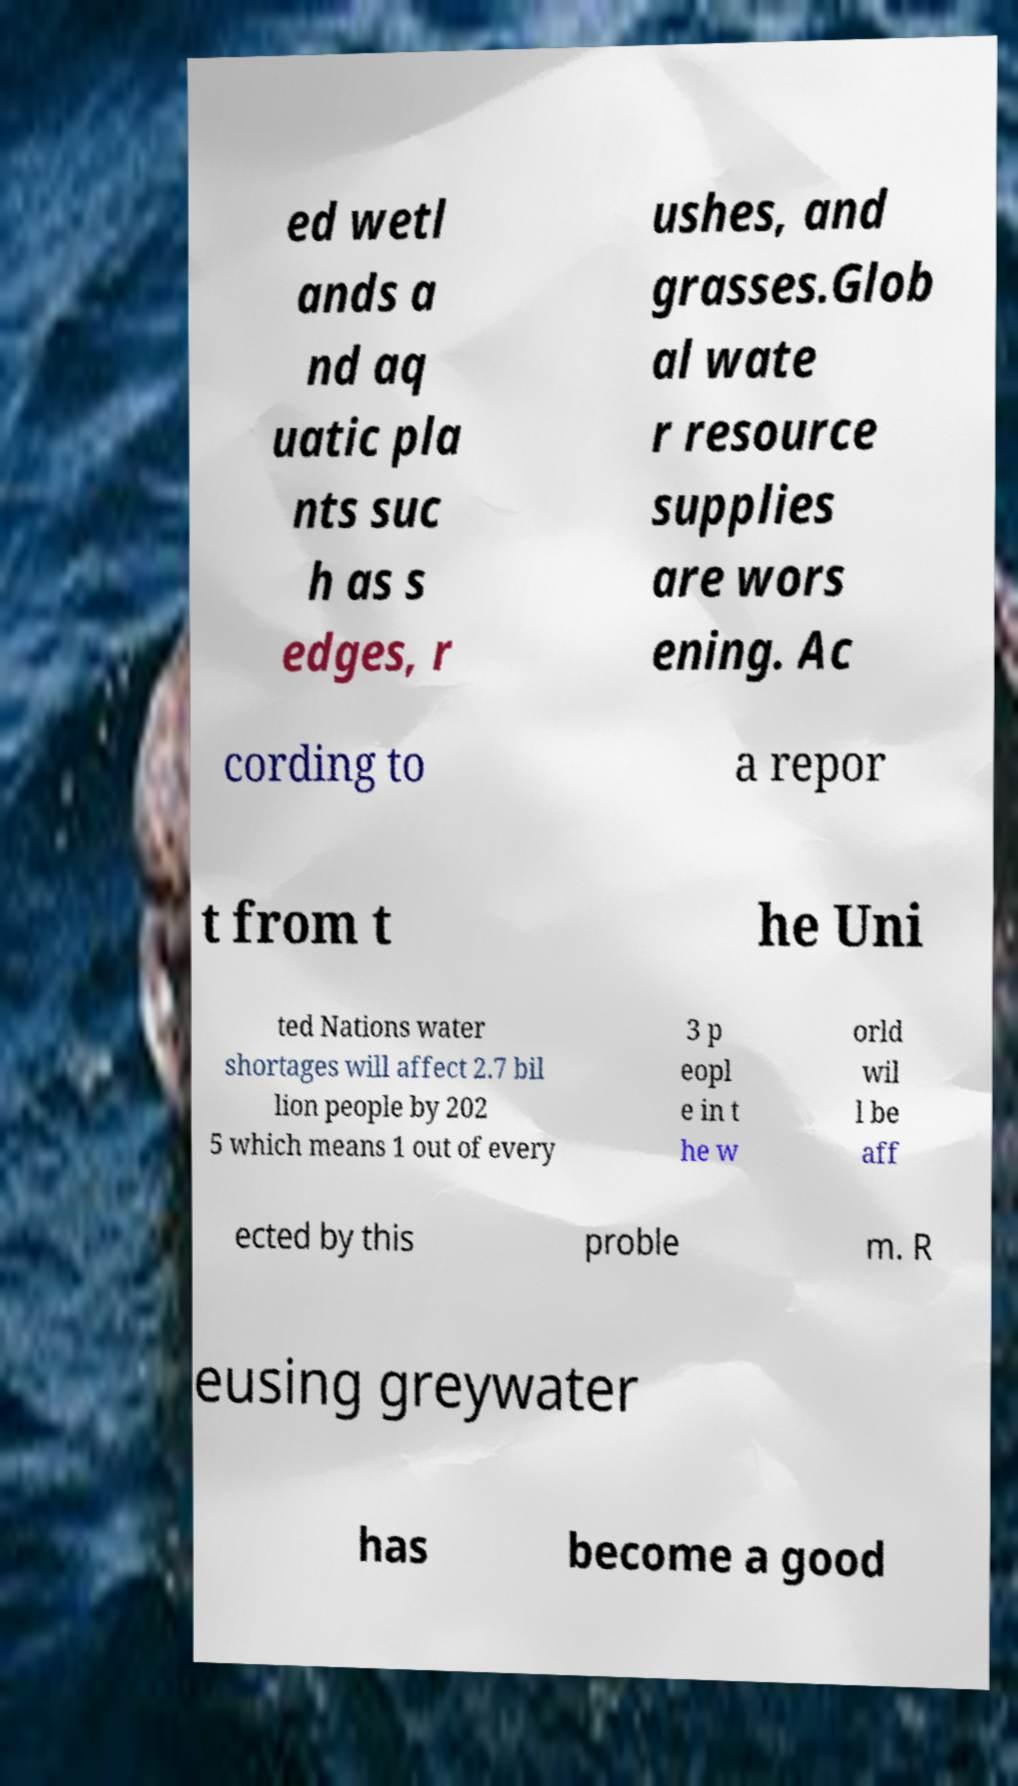There's text embedded in this image that I need extracted. Can you transcribe it verbatim? ed wetl ands a nd aq uatic pla nts suc h as s edges, r ushes, and grasses.Glob al wate r resource supplies are wors ening. Ac cording to a repor t from t he Uni ted Nations water shortages will affect 2.7 bil lion people by 202 5 which means 1 out of every 3 p eopl e in t he w orld wil l be aff ected by this proble m. R eusing greywater has become a good 